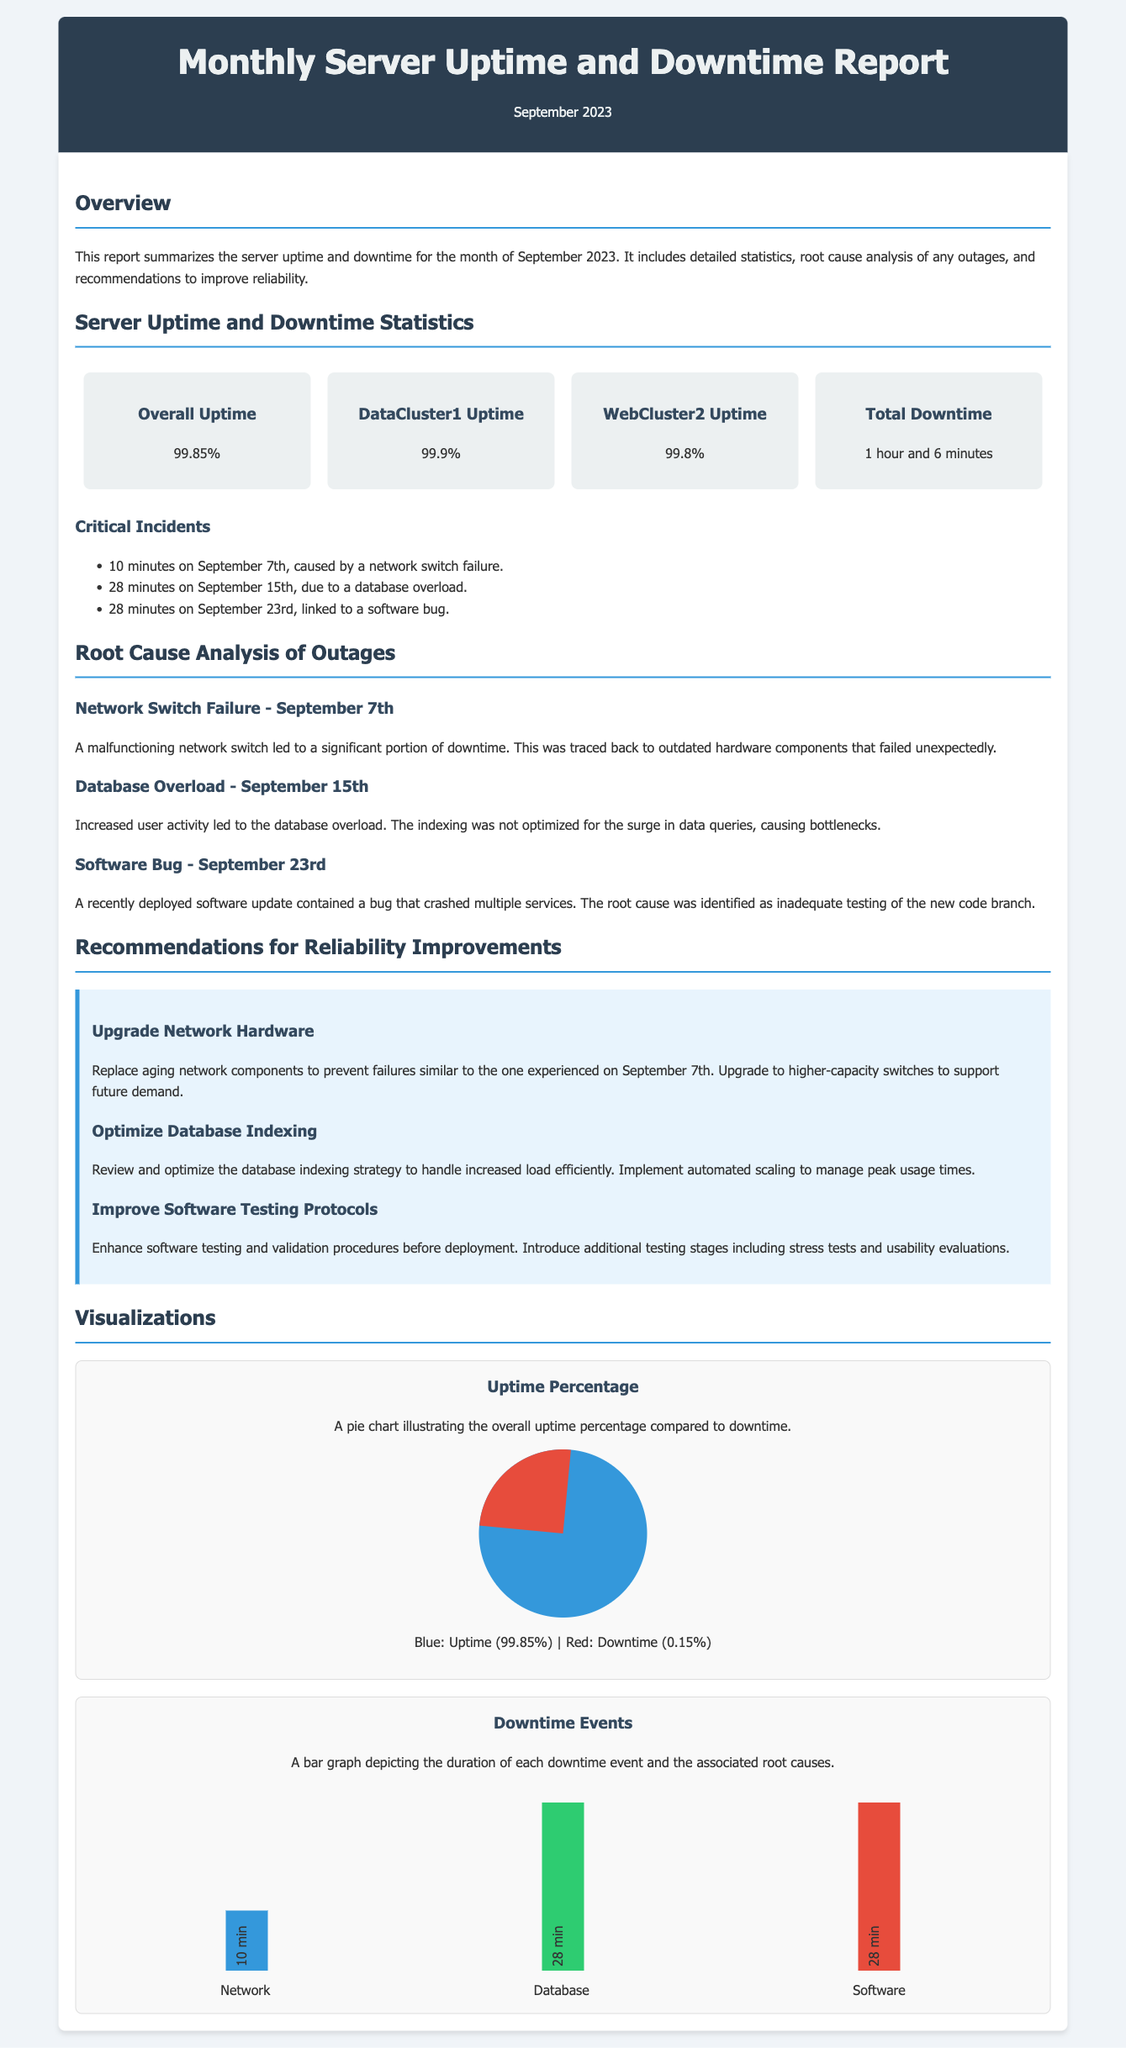What is the overall uptime percentage? The overall uptime percentage is explicitly stated in the statistics section of the document.
Answer: 99.85% What caused the longest downtime event? The longest downtime event of 28 minutes was due to a specific issue explained in the critical incidents section.
Answer: Database overload How many minutes of downtime occurred on September 7th? The downtime that occurred on September 7th is directly mentioned in the critical incidents section.
Answer: 10 minutes What is one recommended improvement for network reliability? The document provides clear recommendations, with one being highlighted in the recommendations section.
Answer: Upgrade network hardware What was the total downtime for the month? The total downtime is reported in the statistics section, summarizing all incidents cumulatively.
Answer: 1 hour and 6 minutes What root cause was identified for the software bug incident? The root cause for the software bug incident is specified in the root cause analysis section.
Answer: Inadequate testing of the new code branch How many critical incidents were identified in the report? The critical incidents section lists each incident individually, allowing for easy counting.
Answer: Three What percentage does downtime represent of the total uptime? The calculation of downtime as a percentage of total uptime is implied through the statistics provided in the document.
Answer: 0.15% 